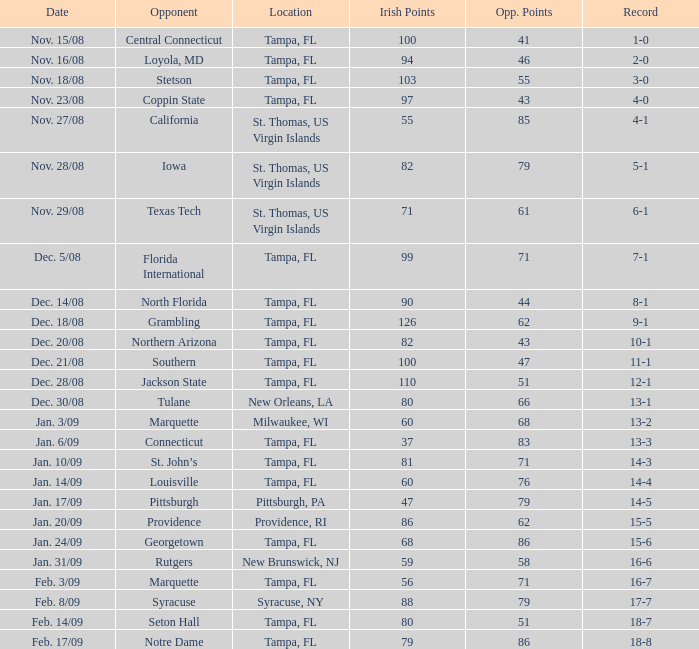What is the record where the locaiton is tampa, fl and the opponent is louisville? 14-4. 